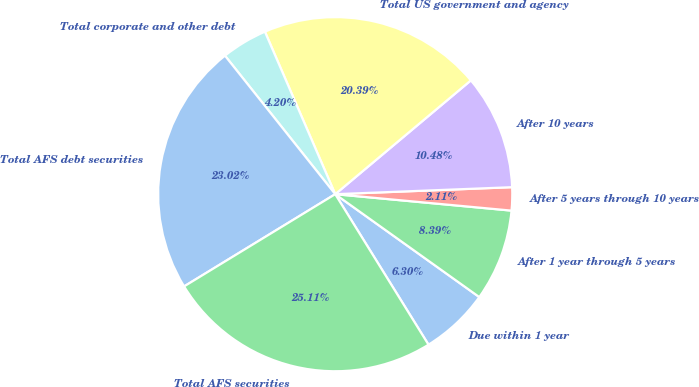Convert chart to OTSL. <chart><loc_0><loc_0><loc_500><loc_500><pie_chart><fcel>Due within 1 year<fcel>After 1 year through 5 years<fcel>After 5 years through 10 years<fcel>After 10 years<fcel>Total US government and agency<fcel>Total corporate and other debt<fcel>Total AFS debt securities<fcel>Total AFS securities<nl><fcel>6.3%<fcel>8.39%<fcel>2.11%<fcel>10.48%<fcel>20.39%<fcel>4.2%<fcel>23.02%<fcel>25.11%<nl></chart> 